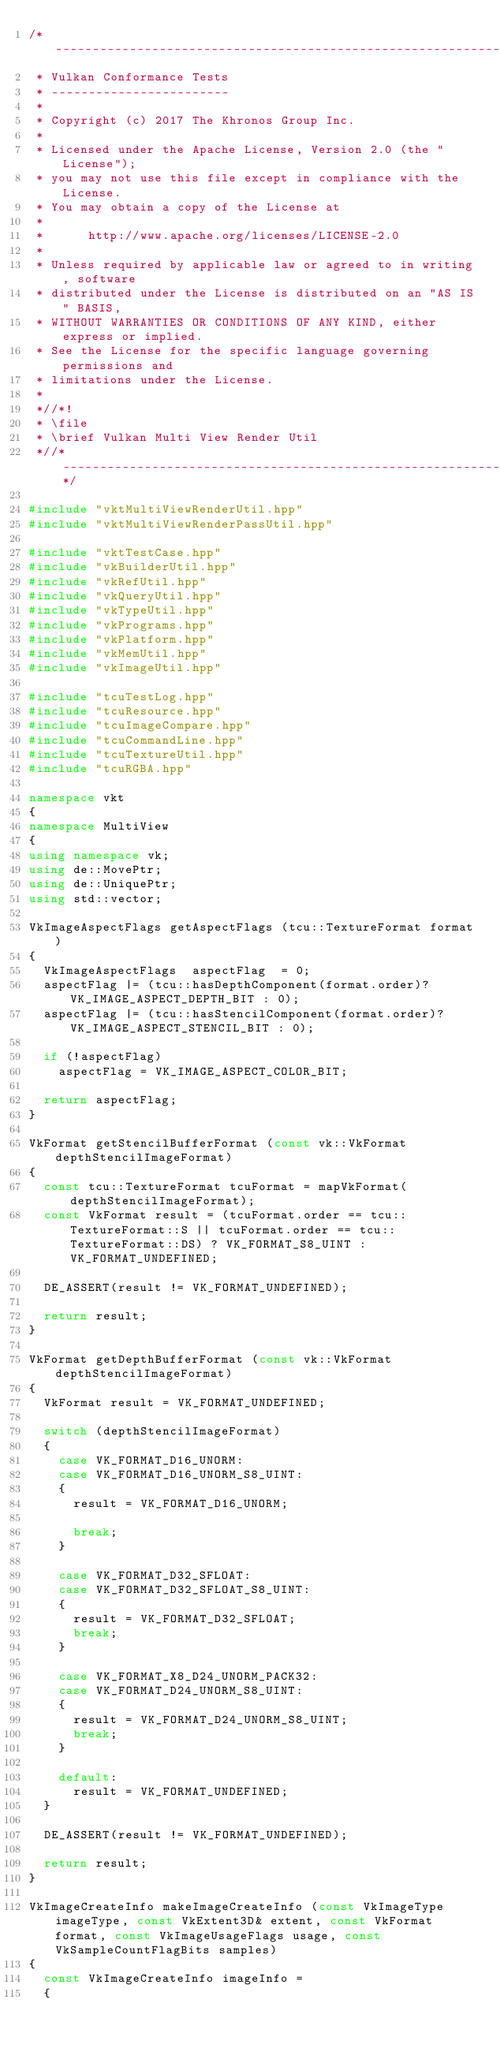Convert code to text. <code><loc_0><loc_0><loc_500><loc_500><_C++_>/*------------------------------------------------------------------------
 * Vulkan Conformance Tests
 * ------------------------
 *
 * Copyright (c) 2017 The Khronos Group Inc.
 *
 * Licensed under the Apache License, Version 2.0 (the "License");
 * you may not use this file except in compliance with the License.
 * You may obtain a copy of the License at
 *
 *      http://www.apache.org/licenses/LICENSE-2.0
 *
 * Unless required by applicable law or agreed to in writing, software
 * distributed under the License is distributed on an "AS IS" BASIS,
 * WITHOUT WARRANTIES OR CONDITIONS OF ANY KIND, either express or implied.
 * See the License for the specific language governing permissions and
 * limitations under the License.
 *
 *//*!
 * \file
 * \brief Vulkan Multi View Render Util
 *//*--------------------------------------------------------------------*/

#include "vktMultiViewRenderUtil.hpp"
#include "vktMultiViewRenderPassUtil.hpp"

#include "vktTestCase.hpp"
#include "vkBuilderUtil.hpp"
#include "vkRefUtil.hpp"
#include "vkQueryUtil.hpp"
#include "vkTypeUtil.hpp"
#include "vkPrograms.hpp"
#include "vkPlatform.hpp"
#include "vkMemUtil.hpp"
#include "vkImageUtil.hpp"

#include "tcuTestLog.hpp"
#include "tcuResource.hpp"
#include "tcuImageCompare.hpp"
#include "tcuCommandLine.hpp"
#include "tcuTextureUtil.hpp"
#include "tcuRGBA.hpp"

namespace vkt
{
namespace MultiView
{
using namespace vk;
using de::MovePtr;
using de::UniquePtr;
using std::vector;

VkImageAspectFlags getAspectFlags (tcu::TextureFormat format)
{
	VkImageAspectFlags	aspectFlag	= 0;
	aspectFlag |= (tcu::hasDepthComponent(format.order)? VK_IMAGE_ASPECT_DEPTH_BIT : 0);
	aspectFlag |= (tcu::hasStencilComponent(format.order)? VK_IMAGE_ASPECT_STENCIL_BIT : 0);

	if (!aspectFlag)
		aspectFlag = VK_IMAGE_ASPECT_COLOR_BIT;

	return aspectFlag;
}

VkFormat getStencilBufferFormat (const vk::VkFormat depthStencilImageFormat)
{
	const tcu::TextureFormat tcuFormat = mapVkFormat(depthStencilImageFormat);
	const VkFormat result = (tcuFormat.order == tcu::TextureFormat::S || tcuFormat.order == tcu::TextureFormat::DS) ? VK_FORMAT_S8_UINT : VK_FORMAT_UNDEFINED;

	DE_ASSERT(result != VK_FORMAT_UNDEFINED);

	return result;
}

VkFormat getDepthBufferFormat (const vk::VkFormat depthStencilImageFormat)
{
	VkFormat result = VK_FORMAT_UNDEFINED;

	switch (depthStencilImageFormat)
	{
		case VK_FORMAT_D16_UNORM:
		case VK_FORMAT_D16_UNORM_S8_UINT:
		{
			result = VK_FORMAT_D16_UNORM;

			break;
		}

		case VK_FORMAT_D32_SFLOAT:
		case VK_FORMAT_D32_SFLOAT_S8_UINT:
		{
			result = VK_FORMAT_D32_SFLOAT;
			break;
		}

		case VK_FORMAT_X8_D24_UNORM_PACK32:
		case VK_FORMAT_D24_UNORM_S8_UINT:
		{
			result = VK_FORMAT_D24_UNORM_S8_UINT;
			break;
		}

		default:
			result = VK_FORMAT_UNDEFINED;
	}

	DE_ASSERT(result != VK_FORMAT_UNDEFINED);

	return result;
}

VkImageCreateInfo makeImageCreateInfo (const VkImageType imageType, const VkExtent3D& extent, const VkFormat format, const VkImageUsageFlags usage, const VkSampleCountFlagBits samples)
{
	const VkImageCreateInfo imageInfo	=
	{</code> 